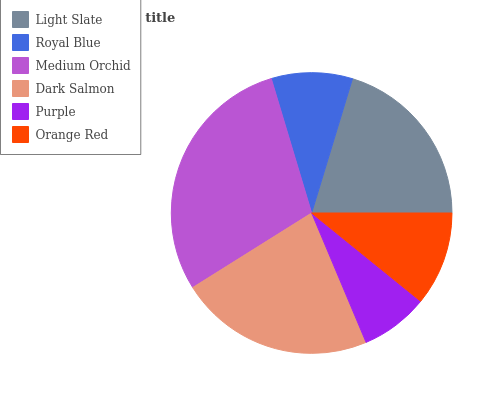Is Purple the minimum?
Answer yes or no. Yes. Is Medium Orchid the maximum?
Answer yes or no. Yes. Is Royal Blue the minimum?
Answer yes or no. No. Is Royal Blue the maximum?
Answer yes or no. No. Is Light Slate greater than Royal Blue?
Answer yes or no. Yes. Is Royal Blue less than Light Slate?
Answer yes or no. Yes. Is Royal Blue greater than Light Slate?
Answer yes or no. No. Is Light Slate less than Royal Blue?
Answer yes or no. No. Is Light Slate the high median?
Answer yes or no. Yes. Is Orange Red the low median?
Answer yes or no. Yes. Is Purple the high median?
Answer yes or no. No. Is Purple the low median?
Answer yes or no. No. 